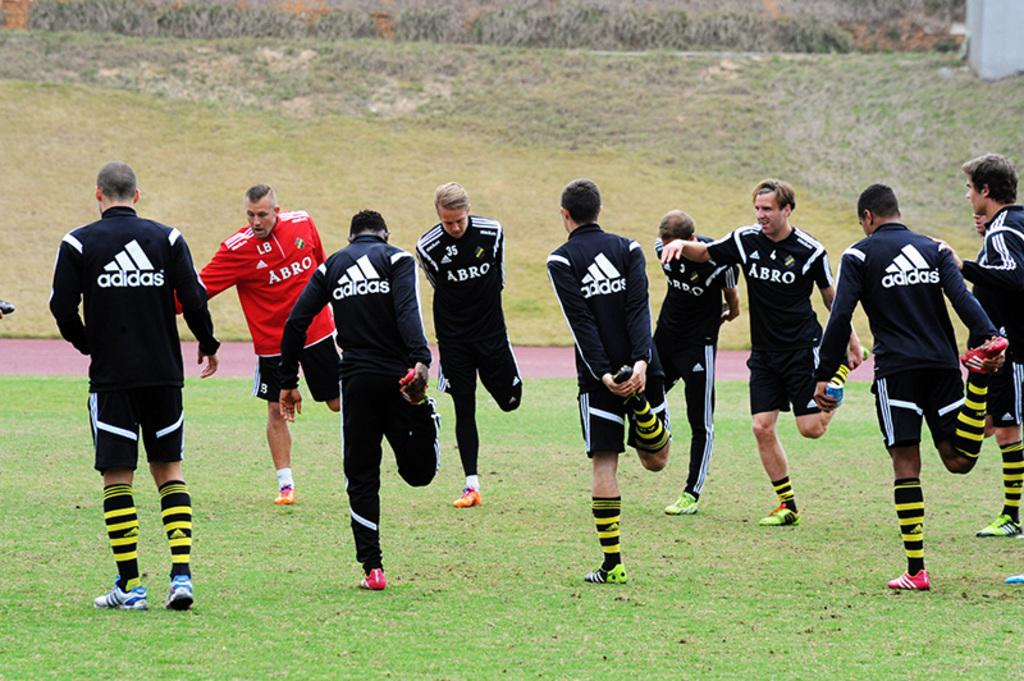<image>
Offer a succinct explanation of the picture presented. Several athletes stretching on a grass field with the brand name adidas on their shirts. 